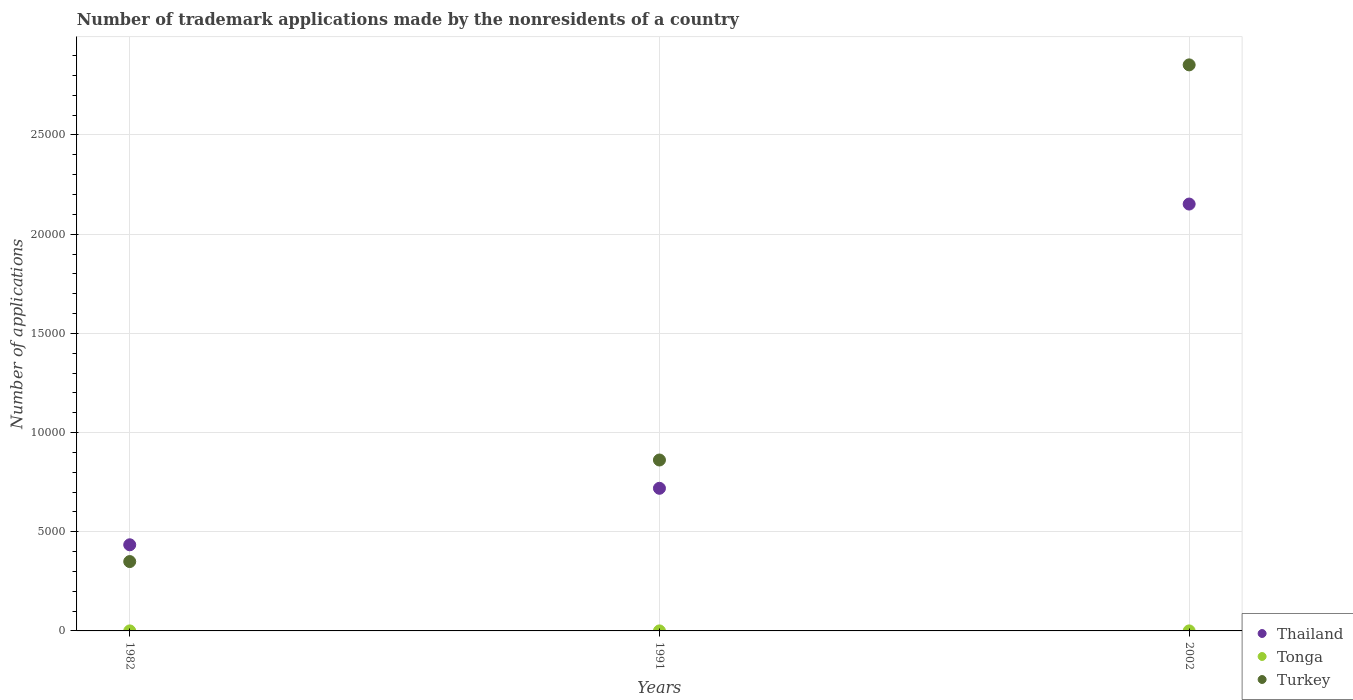How many different coloured dotlines are there?
Ensure brevity in your answer.  3. Is the number of dotlines equal to the number of legend labels?
Provide a short and direct response. Yes. What is the number of trademark applications made by the nonresidents in Turkey in 2002?
Keep it short and to the point. 2.85e+04. Across all years, what is the maximum number of trademark applications made by the nonresidents in Tonga?
Ensure brevity in your answer.  1. In which year was the number of trademark applications made by the nonresidents in Turkey minimum?
Give a very brief answer. 1982. What is the total number of trademark applications made by the nonresidents in Tonga in the graph?
Offer a terse response. 3. What is the difference between the number of trademark applications made by the nonresidents in Tonga in 1991 and that in 2002?
Keep it short and to the point. 0. What is the difference between the number of trademark applications made by the nonresidents in Thailand in 1991 and the number of trademark applications made by the nonresidents in Tonga in 2002?
Keep it short and to the point. 7189. What is the average number of trademark applications made by the nonresidents in Tonga per year?
Your answer should be compact. 1. In the year 1982, what is the difference between the number of trademark applications made by the nonresidents in Tonga and number of trademark applications made by the nonresidents in Thailand?
Your answer should be very brief. -4341. In how many years, is the number of trademark applications made by the nonresidents in Thailand greater than 4000?
Ensure brevity in your answer.  3. What is the ratio of the number of trademark applications made by the nonresidents in Turkey in 1982 to that in 2002?
Your response must be concise. 0.12. Is the number of trademark applications made by the nonresidents in Tonga in 1982 less than that in 2002?
Make the answer very short. No. Is the difference between the number of trademark applications made by the nonresidents in Tonga in 1991 and 2002 greater than the difference between the number of trademark applications made by the nonresidents in Thailand in 1991 and 2002?
Your response must be concise. Yes. What is the difference between the highest and the second highest number of trademark applications made by the nonresidents in Turkey?
Keep it short and to the point. 1.99e+04. What is the difference between the highest and the lowest number of trademark applications made by the nonresidents in Tonga?
Your response must be concise. 0. Is the sum of the number of trademark applications made by the nonresidents in Turkey in 1991 and 2002 greater than the maximum number of trademark applications made by the nonresidents in Tonga across all years?
Offer a terse response. Yes. Does the number of trademark applications made by the nonresidents in Turkey monotonically increase over the years?
Your response must be concise. Yes. Is the number of trademark applications made by the nonresidents in Tonga strictly greater than the number of trademark applications made by the nonresidents in Thailand over the years?
Offer a very short reply. No. Is the number of trademark applications made by the nonresidents in Turkey strictly less than the number of trademark applications made by the nonresidents in Tonga over the years?
Offer a terse response. No. How many dotlines are there?
Keep it short and to the point. 3. How many years are there in the graph?
Keep it short and to the point. 3. What is the difference between two consecutive major ticks on the Y-axis?
Your response must be concise. 5000. Does the graph contain any zero values?
Keep it short and to the point. No. Where does the legend appear in the graph?
Provide a succinct answer. Bottom right. How many legend labels are there?
Your answer should be very brief. 3. How are the legend labels stacked?
Keep it short and to the point. Vertical. What is the title of the graph?
Make the answer very short. Number of trademark applications made by the nonresidents of a country. What is the label or title of the Y-axis?
Provide a succinct answer. Number of applications. What is the Number of applications of Thailand in 1982?
Offer a very short reply. 4342. What is the Number of applications in Tonga in 1982?
Give a very brief answer. 1. What is the Number of applications of Turkey in 1982?
Your answer should be compact. 3496. What is the Number of applications in Thailand in 1991?
Your response must be concise. 7190. What is the Number of applications in Tonga in 1991?
Ensure brevity in your answer.  1. What is the Number of applications in Turkey in 1991?
Offer a terse response. 8616. What is the Number of applications in Thailand in 2002?
Your answer should be compact. 2.15e+04. What is the Number of applications of Tonga in 2002?
Offer a very short reply. 1. What is the Number of applications in Turkey in 2002?
Provide a short and direct response. 2.85e+04. Across all years, what is the maximum Number of applications in Thailand?
Your answer should be compact. 2.15e+04. Across all years, what is the maximum Number of applications in Turkey?
Give a very brief answer. 2.85e+04. Across all years, what is the minimum Number of applications of Thailand?
Your answer should be compact. 4342. Across all years, what is the minimum Number of applications in Turkey?
Offer a very short reply. 3496. What is the total Number of applications of Thailand in the graph?
Provide a succinct answer. 3.30e+04. What is the total Number of applications of Turkey in the graph?
Provide a succinct answer. 4.06e+04. What is the difference between the Number of applications in Thailand in 1982 and that in 1991?
Your answer should be very brief. -2848. What is the difference between the Number of applications of Turkey in 1982 and that in 1991?
Your answer should be compact. -5120. What is the difference between the Number of applications of Thailand in 1982 and that in 2002?
Keep it short and to the point. -1.72e+04. What is the difference between the Number of applications in Tonga in 1982 and that in 2002?
Your response must be concise. 0. What is the difference between the Number of applications in Turkey in 1982 and that in 2002?
Offer a very short reply. -2.50e+04. What is the difference between the Number of applications in Thailand in 1991 and that in 2002?
Provide a succinct answer. -1.43e+04. What is the difference between the Number of applications of Tonga in 1991 and that in 2002?
Make the answer very short. 0. What is the difference between the Number of applications in Turkey in 1991 and that in 2002?
Keep it short and to the point. -1.99e+04. What is the difference between the Number of applications in Thailand in 1982 and the Number of applications in Tonga in 1991?
Offer a terse response. 4341. What is the difference between the Number of applications in Thailand in 1982 and the Number of applications in Turkey in 1991?
Keep it short and to the point. -4274. What is the difference between the Number of applications of Tonga in 1982 and the Number of applications of Turkey in 1991?
Provide a short and direct response. -8615. What is the difference between the Number of applications of Thailand in 1982 and the Number of applications of Tonga in 2002?
Your answer should be very brief. 4341. What is the difference between the Number of applications in Thailand in 1982 and the Number of applications in Turkey in 2002?
Your answer should be compact. -2.42e+04. What is the difference between the Number of applications in Tonga in 1982 and the Number of applications in Turkey in 2002?
Make the answer very short. -2.85e+04. What is the difference between the Number of applications in Thailand in 1991 and the Number of applications in Tonga in 2002?
Provide a short and direct response. 7189. What is the difference between the Number of applications in Thailand in 1991 and the Number of applications in Turkey in 2002?
Keep it short and to the point. -2.13e+04. What is the difference between the Number of applications of Tonga in 1991 and the Number of applications of Turkey in 2002?
Keep it short and to the point. -2.85e+04. What is the average Number of applications of Thailand per year?
Ensure brevity in your answer.  1.10e+04. What is the average Number of applications of Turkey per year?
Offer a very short reply. 1.35e+04. In the year 1982, what is the difference between the Number of applications of Thailand and Number of applications of Tonga?
Your answer should be very brief. 4341. In the year 1982, what is the difference between the Number of applications in Thailand and Number of applications in Turkey?
Your response must be concise. 846. In the year 1982, what is the difference between the Number of applications in Tonga and Number of applications in Turkey?
Give a very brief answer. -3495. In the year 1991, what is the difference between the Number of applications of Thailand and Number of applications of Tonga?
Provide a short and direct response. 7189. In the year 1991, what is the difference between the Number of applications in Thailand and Number of applications in Turkey?
Your answer should be compact. -1426. In the year 1991, what is the difference between the Number of applications of Tonga and Number of applications of Turkey?
Keep it short and to the point. -8615. In the year 2002, what is the difference between the Number of applications in Thailand and Number of applications in Tonga?
Offer a very short reply. 2.15e+04. In the year 2002, what is the difference between the Number of applications in Thailand and Number of applications in Turkey?
Your answer should be compact. -7016. In the year 2002, what is the difference between the Number of applications of Tonga and Number of applications of Turkey?
Your response must be concise. -2.85e+04. What is the ratio of the Number of applications in Thailand in 1982 to that in 1991?
Provide a short and direct response. 0.6. What is the ratio of the Number of applications of Tonga in 1982 to that in 1991?
Your response must be concise. 1. What is the ratio of the Number of applications in Turkey in 1982 to that in 1991?
Make the answer very short. 0.41. What is the ratio of the Number of applications of Thailand in 1982 to that in 2002?
Provide a succinct answer. 0.2. What is the ratio of the Number of applications in Tonga in 1982 to that in 2002?
Provide a short and direct response. 1. What is the ratio of the Number of applications of Turkey in 1982 to that in 2002?
Keep it short and to the point. 0.12. What is the ratio of the Number of applications of Thailand in 1991 to that in 2002?
Provide a short and direct response. 0.33. What is the ratio of the Number of applications of Turkey in 1991 to that in 2002?
Keep it short and to the point. 0.3. What is the difference between the highest and the second highest Number of applications in Thailand?
Offer a very short reply. 1.43e+04. What is the difference between the highest and the second highest Number of applications in Tonga?
Your response must be concise. 0. What is the difference between the highest and the second highest Number of applications in Turkey?
Provide a short and direct response. 1.99e+04. What is the difference between the highest and the lowest Number of applications of Thailand?
Keep it short and to the point. 1.72e+04. What is the difference between the highest and the lowest Number of applications of Tonga?
Make the answer very short. 0. What is the difference between the highest and the lowest Number of applications in Turkey?
Offer a very short reply. 2.50e+04. 